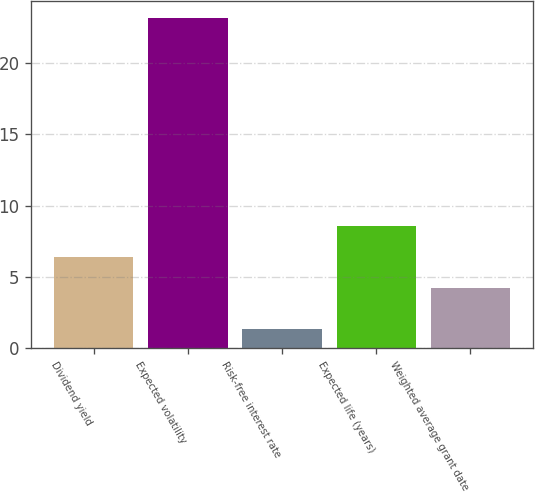Convert chart to OTSL. <chart><loc_0><loc_0><loc_500><loc_500><bar_chart><fcel>Dividend yield<fcel>Expected volatility<fcel>Risk-free interest rate<fcel>Expected life (years)<fcel>Weighted average grant date<nl><fcel>6.37<fcel>23.2<fcel>1.3<fcel>8.56<fcel>4.18<nl></chart> 